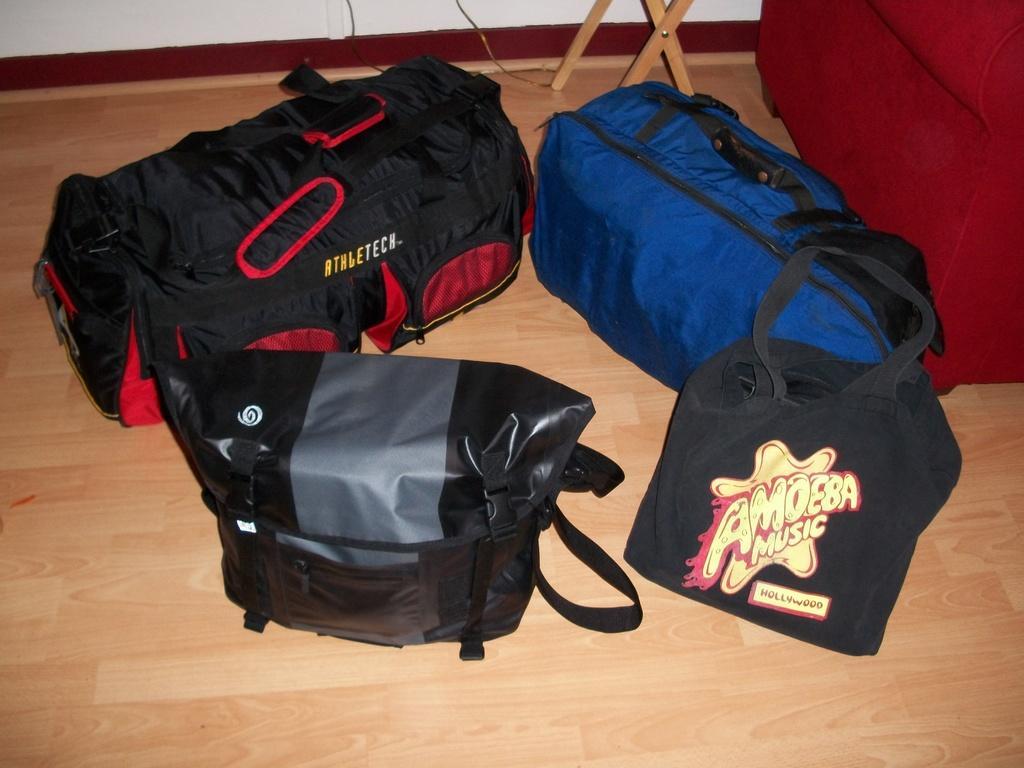Could you give a brief overview of what you see in this image? In this picture the four different sizes of bags kept on the floor, one is black color on other one is blue and the next one is black and red and in the last one is black and ash these are kept beside the couch and the table behind in those also wall and floor is made up of wood 